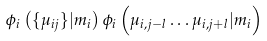<formula> <loc_0><loc_0><loc_500><loc_500>\phi _ { i } \left ( \{ \mu _ { i j } \} | m _ { i } \right ) \phi _ { i } \left ( \mu _ { i , j - l } \dots \mu _ { i , j + l } | m _ { i } \right )</formula> 